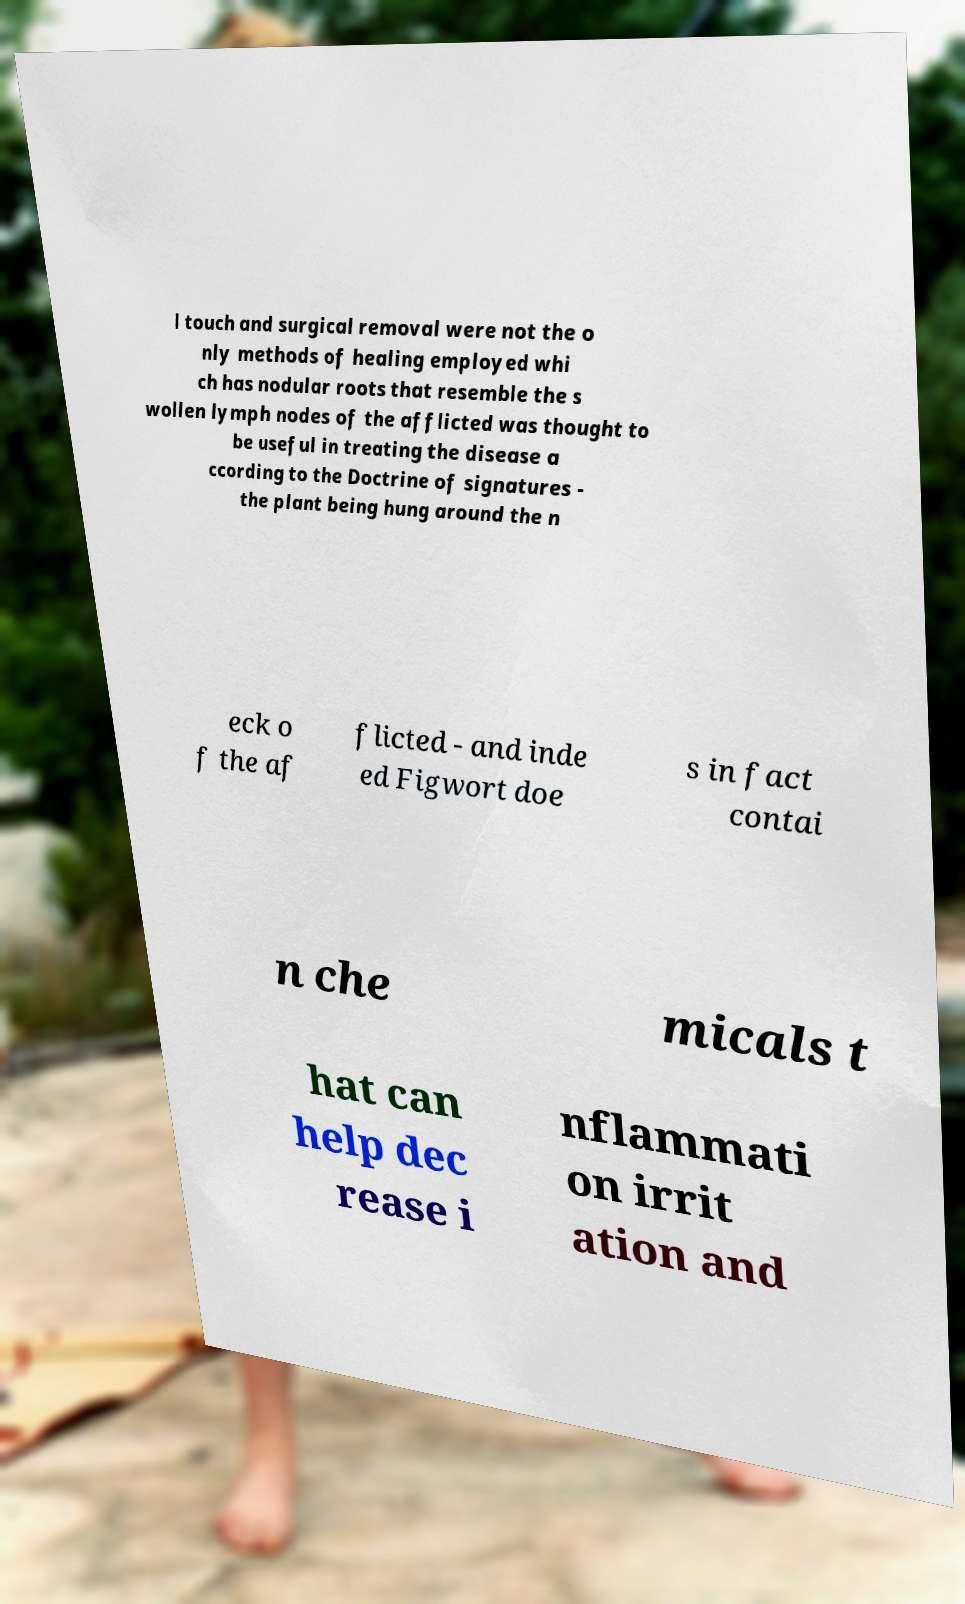Can you read and provide the text displayed in the image?This photo seems to have some interesting text. Can you extract and type it out for me? l touch and surgical removal were not the o nly methods of healing employed whi ch has nodular roots that resemble the s wollen lymph nodes of the afflicted was thought to be useful in treating the disease a ccording to the Doctrine of signatures - the plant being hung around the n eck o f the af flicted - and inde ed Figwort doe s in fact contai n che micals t hat can help dec rease i nflammati on irrit ation and 